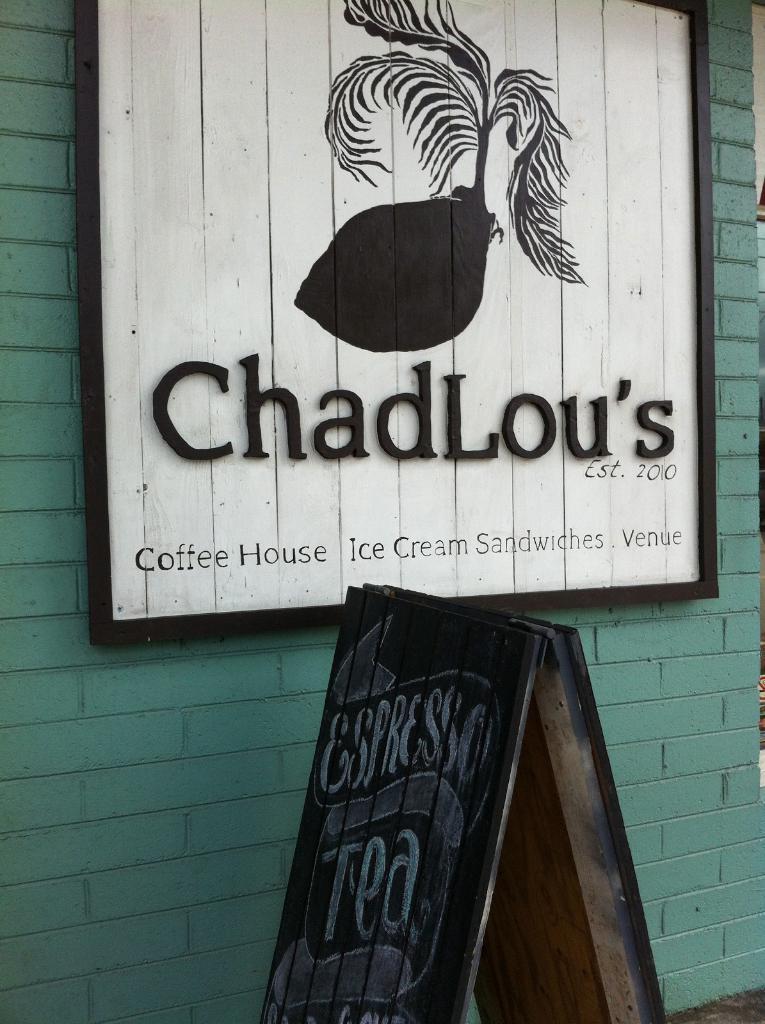Can you describe this image briefly? There is a wall. On the wall there is a board with something written. Also there is a drawing on the board. Near to the wall there is another stand. On that there is something written. 